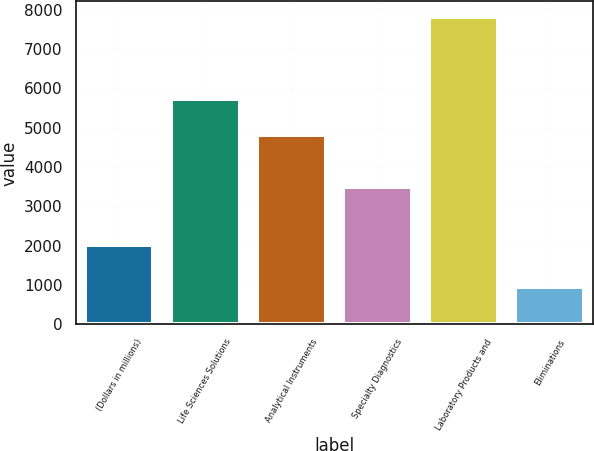Convert chart to OTSL. <chart><loc_0><loc_0><loc_500><loc_500><bar_chart><fcel>(Dollars in millions)<fcel>Life Sciences Solutions<fcel>Analytical Instruments<fcel>Specialty Diagnostics<fcel>Laboratory Products and<fcel>Eliminations<nl><fcel>2017<fcel>5728<fcel>4821<fcel>3486<fcel>7825<fcel>942<nl></chart> 